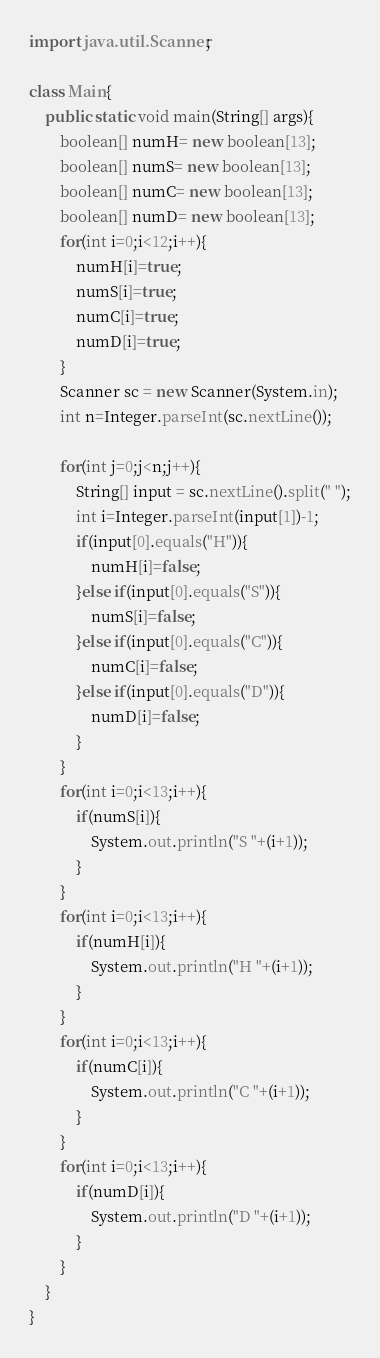Convert code to text. <code><loc_0><loc_0><loc_500><loc_500><_Java_>import java.util.Scanner;

class Main{
	public static void main(String[] args){
		boolean[] numH= new boolean[13];
		boolean[] numS= new boolean[13];
		boolean[] numC= new boolean[13];
		boolean[] numD= new boolean[13];
		for(int i=0;i<12;i++){
			numH[i]=true;
			numS[i]=true;
			numC[i]=true;
			numD[i]=true;
		}
		Scanner sc = new Scanner(System.in);
		int n=Integer.parseInt(sc.nextLine());

		for(int j=0;j<n;j++){
			String[] input = sc.nextLine().split(" ");
			int i=Integer.parseInt(input[1])-1;
			if(input[0].equals("H")){
				numH[i]=false;
			}else if(input[0].equals("S")){
				numS[i]=false;
			}else if(input[0].equals("C")){
				numC[i]=false;
			}else if(input[0].equals("D")){
				numD[i]=false;
			}
		}
		for(int i=0;i<13;i++){
			if(numS[i]){
				System.out.println("S "+(i+1));
			}
		}
		for(int i=0;i<13;i++){
			if(numH[i]){
				System.out.println("H "+(i+1));
			}
		}
		for(int i=0;i<13;i++){
			if(numC[i]){
				System.out.println("C "+(i+1));
			}
		}
		for(int i=0;i<13;i++){
			if(numD[i]){
				System.out.println("D "+(i+1));
			}
		}
	}
}</code> 